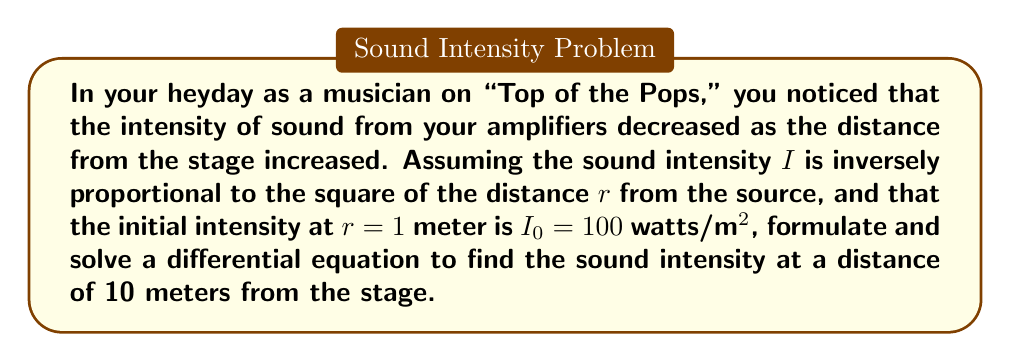Provide a solution to this math problem. 1) We start with the inverse square law for sound intensity:
   $I \propto \frac{1}{r^2}$

2) This can be written as a differential equation:
   $$\frac{dI}{dr} = -k\frac{I}{r^2}$$
   where $k$ is a constant of proportionality.

3) Separating variables:
   $$\frac{dI}{I} = -k\frac{dr}{r^2}$$

4) Integrating both sides:
   $$\int \frac{dI}{I} = -k\int \frac{dr}{r^2}$$

5) This gives us:
   $$\ln|I| = \frac{k}{r} + C$$

6) Taking the exponential of both sides:
   $$I = Ae^{\frac{k}{r}}$$
   where $A = e^C$

7) Using the initial condition $I = I_0 = 100$ when $r = 1$:
   $$100 = Ae^k$$
   $$A = 100e^{-k}$$

8) Substituting this back into our general solution:
   $$I = 100e^{-k}e^{\frac{k}{r}} = 100e^{k(\frac{1}{r}-1)}$$

9) To find $k$, we can use the fact that $I \propto \frac{1}{r^2}$:
   $$100e^{k(\frac{1}{r}-1)} = \frac{100}{r^2}$$
   $$e^{k(\frac{1}{r}-1)} = \frac{1}{r^2}$$

10) This equality holds for all $r$, so we can choose $r=2$ for simplicity:
    $$e^{k(\frac{1}{2}-1)} = \frac{1}{2^2}$$
    $$e^{-\frac{k}{2}} = \frac{1}{4}$$
    $$-\frac{k}{2} = \ln(\frac{1}{4}) = -\ln(4)$$
    $$k = 2\ln(4)$$

11) Now we can find the intensity at 10 meters:
    $$I = 100e^{2\ln(4)(\frac{1}{10}-1)} = 100e^{2\ln(4)(-0.9)} = 100(4^{-0.9}) = 1 \text{ watt/m²}$$
Answer: $1$ watt/m² 